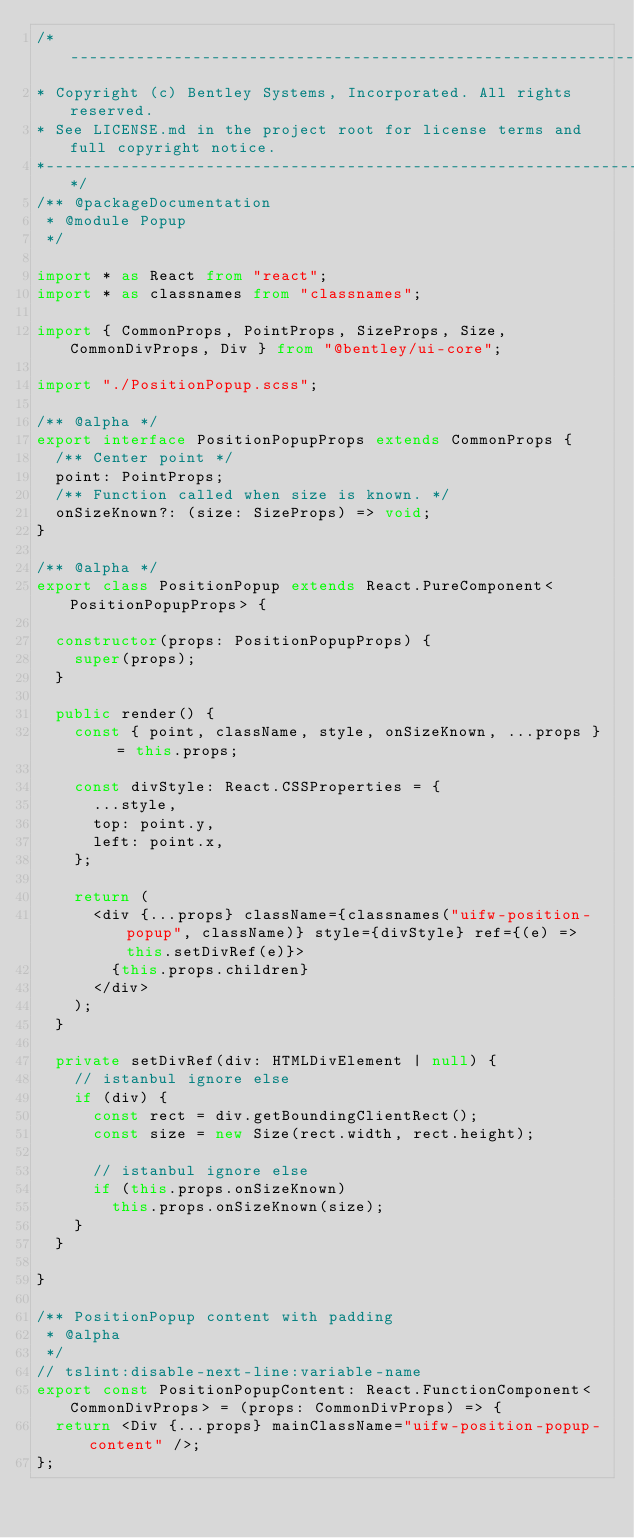<code> <loc_0><loc_0><loc_500><loc_500><_TypeScript_>/*---------------------------------------------------------------------------------------------
* Copyright (c) Bentley Systems, Incorporated. All rights reserved.
* See LICENSE.md in the project root for license terms and full copyright notice.
*--------------------------------------------------------------------------------------------*/
/** @packageDocumentation
 * @module Popup
 */

import * as React from "react";
import * as classnames from "classnames";

import { CommonProps, PointProps, SizeProps, Size, CommonDivProps, Div } from "@bentley/ui-core";

import "./PositionPopup.scss";

/** @alpha */
export interface PositionPopupProps extends CommonProps {
  /** Center point */
  point: PointProps;
  /** Function called when size is known. */
  onSizeKnown?: (size: SizeProps) => void;
}

/** @alpha */
export class PositionPopup extends React.PureComponent<PositionPopupProps> {

  constructor(props: PositionPopupProps) {
    super(props);
  }

  public render() {
    const { point, className, style, onSizeKnown, ...props } = this.props;

    const divStyle: React.CSSProperties = {
      ...style,
      top: point.y,
      left: point.x,
    };

    return (
      <div {...props} className={classnames("uifw-position-popup", className)} style={divStyle} ref={(e) => this.setDivRef(e)}>
        {this.props.children}
      </div>
    );
  }

  private setDivRef(div: HTMLDivElement | null) {
    // istanbul ignore else
    if (div) {
      const rect = div.getBoundingClientRect();
      const size = new Size(rect.width, rect.height);

      // istanbul ignore else
      if (this.props.onSizeKnown)
        this.props.onSizeKnown(size);
    }
  }

}

/** PositionPopup content with padding
 * @alpha
 */
// tslint:disable-next-line:variable-name
export const PositionPopupContent: React.FunctionComponent<CommonDivProps> = (props: CommonDivProps) => {
  return <Div {...props} mainClassName="uifw-position-popup-content" />;
};
</code> 